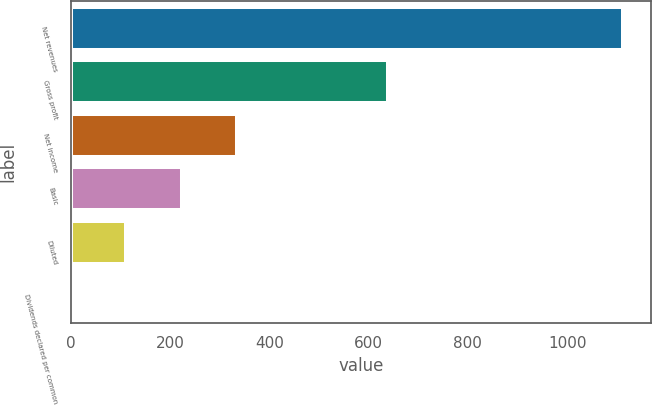Convert chart. <chart><loc_0><loc_0><loc_500><loc_500><bar_chart><fcel>Net revenues<fcel>Gross profit<fcel>Net income<fcel>Basic<fcel>Diluted<fcel>Dividends declared per common<nl><fcel>1113.6<fcel>638.4<fcel>334.12<fcel>222.76<fcel>111.41<fcel>0.05<nl></chart> 